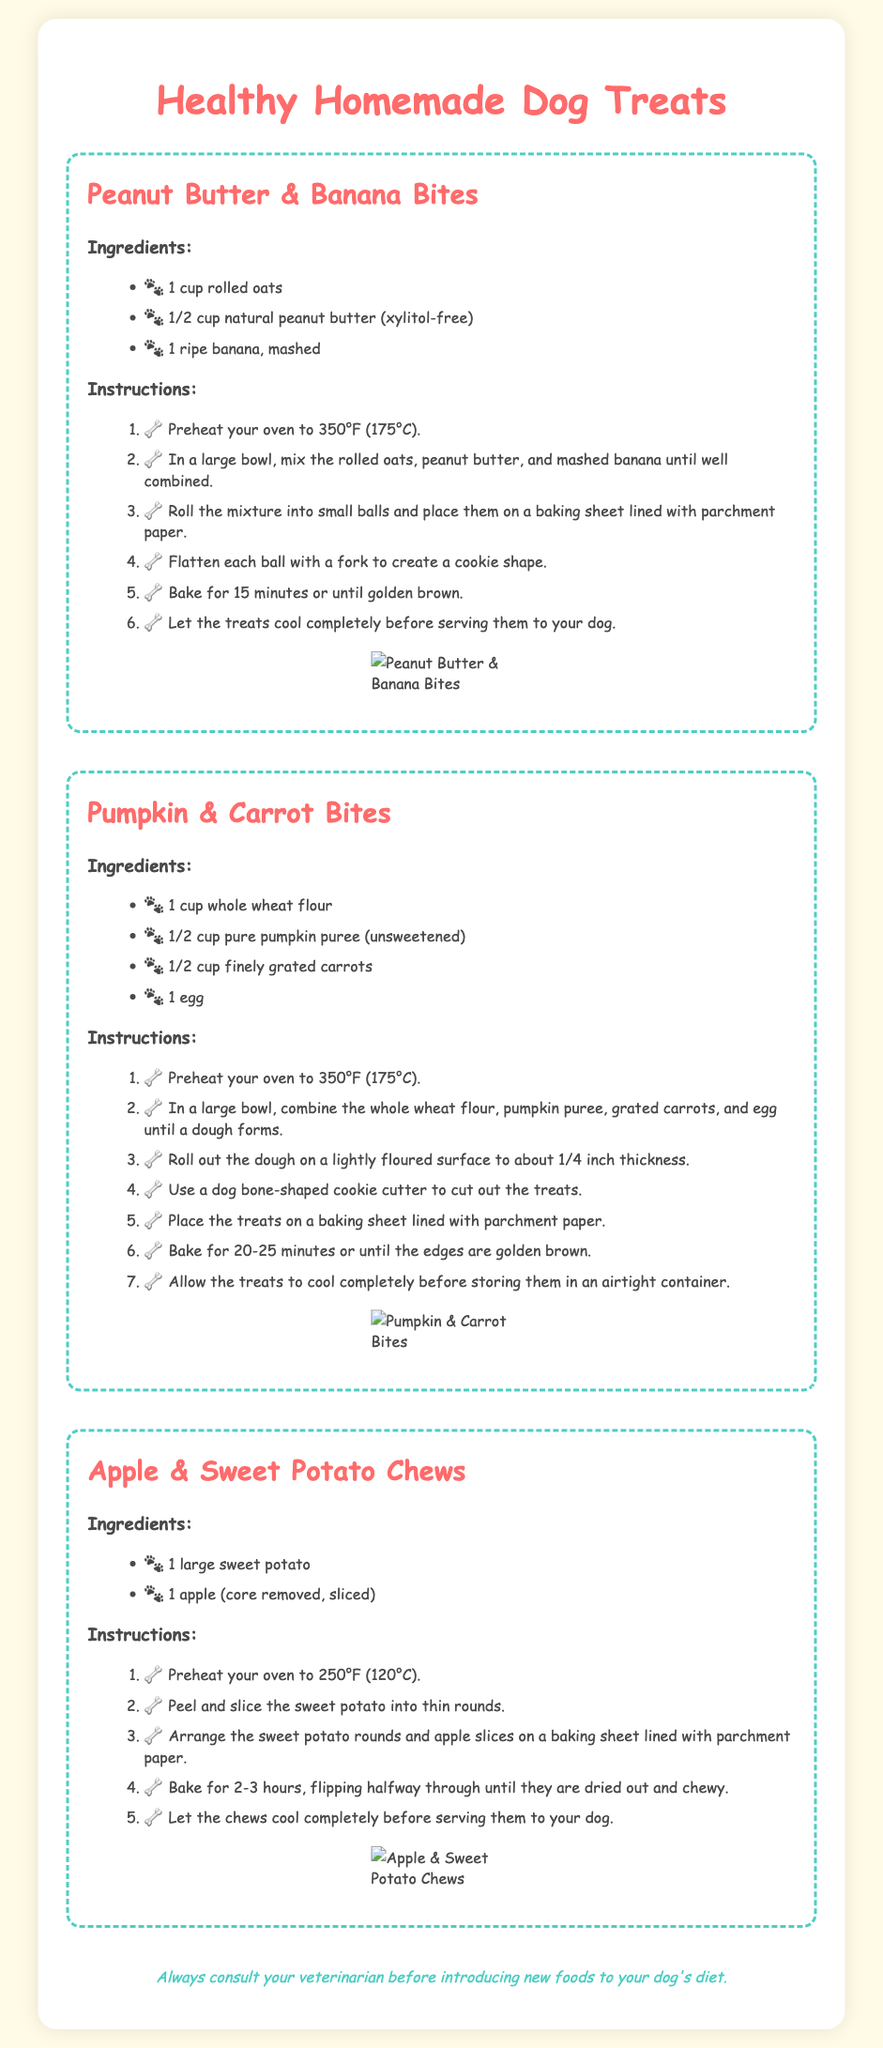what is the first ingredient in Peanut Butter & Banana Bites? The first ingredient is listed in the document under the Peanut Butter & Banana Bites section.
Answer: 1 cup rolled oats how many ingredients are listed for Pumpkin & Carrot Bites? The number of ingredients is found by counting the items under the Ingredients section for Pumpkin & Carrot Bites.
Answer: 4 what is the baking temperature for Apple & Sweet Potato Chews? The baking temperature is mentioned in the instructions for Apple & Sweet Potato Chews.
Answer: 250°F (120°C) how long should you bake the Peanut Butter & Banana Bites? The baking time is specified in the instructions for the Peanut Butter & Banana Bites section.
Answer: 15 minutes which treat requires an egg as an ingredient? This can be determined by reviewing the ingredients listed for each treat in the document.
Answer: Pumpkin & Carrot Bites what shape should the treats be cut into for Pumpkin & Carrot Bites? The shape is specified in the instructions for Pumpkin & Carrot Bites.
Answer: dog bone-shaped how long do you bake the Apple & Sweet Potato Chews? This information is found in the instructions for Apple & Sweet Potato Chews detailing the baking duration.
Answer: 2-3 hours what is the last instruction for Peanut Butter & Banana Bites? The last instruction is found in the list of instructions for the Peanut Butter & Banana Bites.
Answer: Let the treats cool completely before serving them to your dog 